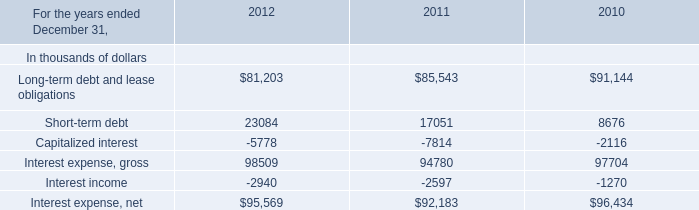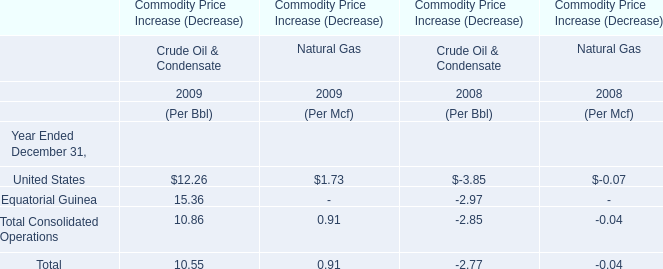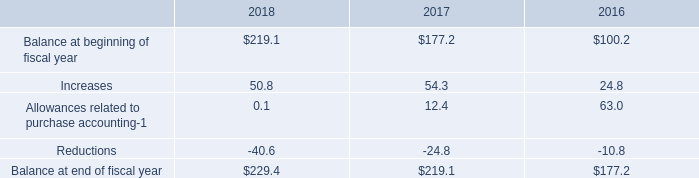What's the sum of all Crude Oil & Condensate that are positive in 2009 for Commodity Price Increase (Decrease)？ 
Computations: (((12.26 + 15.36) + 10.86) + 10.55)
Answer: 49.03. 